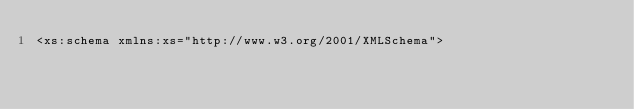Convert code to text. <code><loc_0><loc_0><loc_500><loc_500><_XML_><xs:schema xmlns:xs="http://www.w3.org/2001/XMLSchema"></code> 